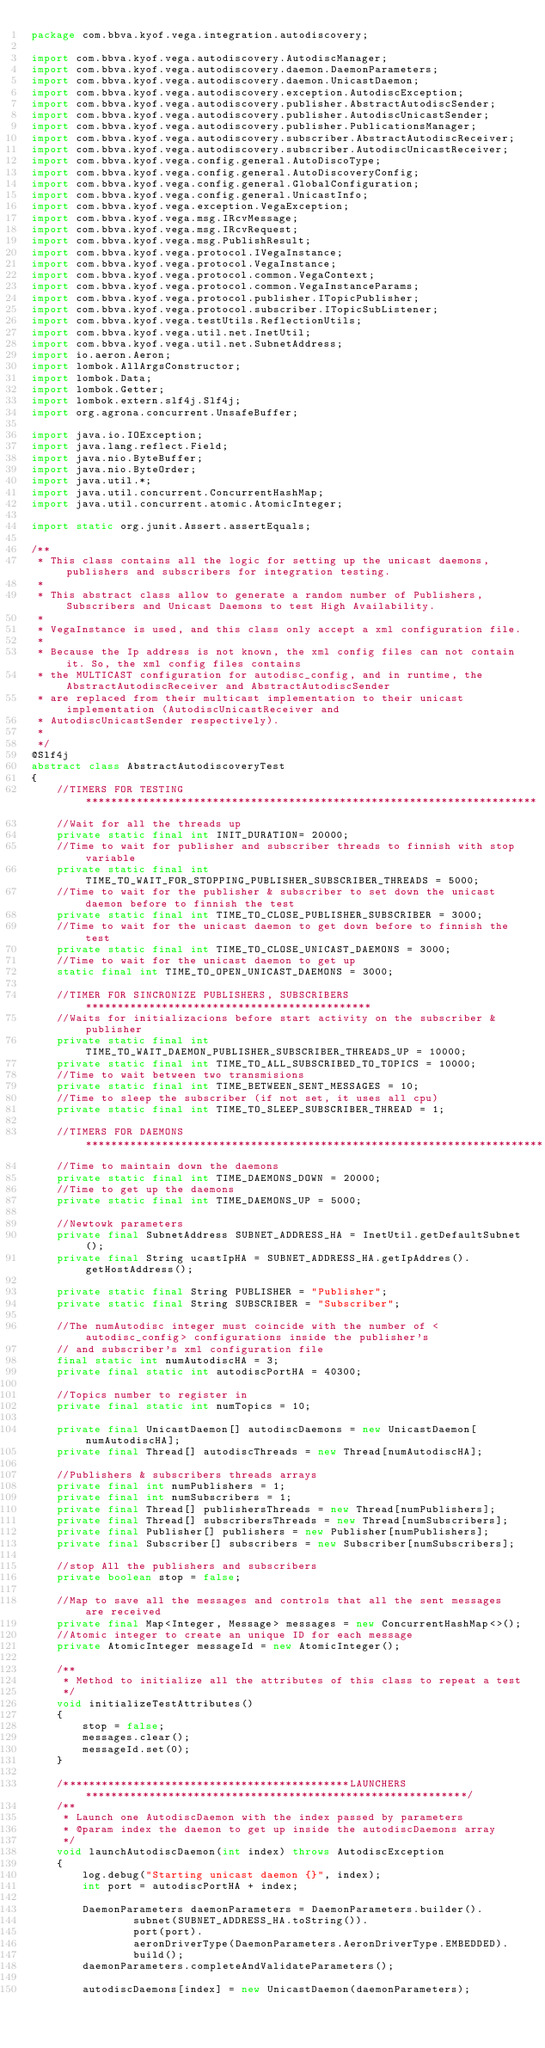Convert code to text. <code><loc_0><loc_0><loc_500><loc_500><_Java_>package com.bbva.kyof.vega.integration.autodiscovery;

import com.bbva.kyof.vega.autodiscovery.AutodiscManager;
import com.bbva.kyof.vega.autodiscovery.daemon.DaemonParameters;
import com.bbva.kyof.vega.autodiscovery.daemon.UnicastDaemon;
import com.bbva.kyof.vega.autodiscovery.exception.AutodiscException;
import com.bbva.kyof.vega.autodiscovery.publisher.AbstractAutodiscSender;
import com.bbva.kyof.vega.autodiscovery.publisher.AutodiscUnicastSender;
import com.bbva.kyof.vega.autodiscovery.publisher.PublicationsManager;
import com.bbva.kyof.vega.autodiscovery.subscriber.AbstractAutodiscReceiver;
import com.bbva.kyof.vega.autodiscovery.subscriber.AutodiscUnicastReceiver;
import com.bbva.kyof.vega.config.general.AutoDiscoType;
import com.bbva.kyof.vega.config.general.AutoDiscoveryConfig;
import com.bbva.kyof.vega.config.general.GlobalConfiguration;
import com.bbva.kyof.vega.config.general.UnicastInfo;
import com.bbva.kyof.vega.exception.VegaException;
import com.bbva.kyof.vega.msg.IRcvMessage;
import com.bbva.kyof.vega.msg.IRcvRequest;
import com.bbva.kyof.vega.msg.PublishResult;
import com.bbva.kyof.vega.protocol.IVegaInstance;
import com.bbva.kyof.vega.protocol.VegaInstance;
import com.bbva.kyof.vega.protocol.common.VegaContext;
import com.bbva.kyof.vega.protocol.common.VegaInstanceParams;
import com.bbva.kyof.vega.protocol.publisher.ITopicPublisher;
import com.bbva.kyof.vega.protocol.subscriber.ITopicSubListener;
import com.bbva.kyof.vega.testUtils.ReflectionUtils;
import com.bbva.kyof.vega.util.net.InetUtil;
import com.bbva.kyof.vega.util.net.SubnetAddress;
import io.aeron.Aeron;
import lombok.AllArgsConstructor;
import lombok.Data;
import lombok.Getter;
import lombok.extern.slf4j.Slf4j;
import org.agrona.concurrent.UnsafeBuffer;

import java.io.IOException;
import java.lang.reflect.Field;
import java.nio.ByteBuffer;
import java.nio.ByteOrder;
import java.util.*;
import java.util.concurrent.ConcurrentHashMap;
import java.util.concurrent.atomic.AtomicInteger;

import static org.junit.Assert.assertEquals;

/**
 * This class contains all the logic for setting up the unicast daemons, publishers and subscribers for integration testing.
 *
 * This abstract class allow to generate a random number of Publishers, Subscribers and Unicast Daemons to test High Availability.
 *
 * VegaInstance is used, and this class only accept a xml configuration file.
 *
 * Because the Ip address is not known, the xml config files can not contain it. So, the xml config files contains
 * the MULTICAST configuration for autodisc_config, and in runtime, the AbstractAutodiscReceiver and AbstractAutodiscSender
 * are replaced from their multicast implementation to their unicast implementation (AutodiscUnicastReceiver and
 * AutodiscUnicastSender respectively).
 *
 */
@Slf4j
abstract class AbstractAutodiscoveryTest
{
    //TIMERS FOR TESTING  ***********************************************************************
    //Wait for all the threads up
    private static final int INIT_DURATION= 20000;
    //Time to wait for publisher and subscriber threads to finnish with stop variable
    private static final int TIME_TO_WAIT_FOR_STOPPING_PUBLISHER_SUBSCRIBER_THREADS = 5000;
    //Time to wait for the publisher & subscriber to set down the unicast daemon before to finnish the test
    private static final int TIME_TO_CLOSE_PUBLISHER_SUBSCRIBER = 3000;
    //Time to wait for the unicast daemon to get down before to finnish the test
    private static final int TIME_TO_CLOSE_UNICAST_DAEMONS = 3000;
    //Time to wait for the unicast daemon to get up
    static final int TIME_TO_OPEN_UNICAST_DAEMONS = 3000;

    //TIMER FOR SINCRONIZE PUBLISHERS, SUBSCRIBERS  *********************************************
    //Waits for initializacions before start activity on the subscriber & publisher
    private static final int TIME_TO_WAIT_DAEMON_PUBLISHER_SUBSCRIBER_THREADS_UP = 10000;
    private static final int TIME_TO_ALL_SUBSCRIBED_TO_TOPICS = 10000;
    //Time to wait between two transmisions
    private static final int TIME_BETWEEN_SENT_MESSAGES = 10;
    //Time to sleep the subscriber (if not set, it uses all cpu)
    private static final int TIME_TO_SLEEP_SUBSCRIBER_THREAD = 1;

    //TIMERS FOR DAEMONS ************************************************************************
    //Time to maintain down the daemons
    private static final int TIME_DAEMONS_DOWN = 20000;
    //Time to get up the daemons
    private static final int TIME_DAEMONS_UP = 5000;

    //Newtowk parameters
    private final SubnetAddress SUBNET_ADDRESS_HA = InetUtil.getDefaultSubnet();
    private final String ucastIpHA = SUBNET_ADDRESS_HA.getIpAddres().getHostAddress();

    private static final String PUBLISHER = "Publisher";
    private static final String SUBSCRIBER = "Subscriber";

    //The numAutodisc integer must coincide with the number of <autodisc_config> configurations inside the publisher's
    // and subscriber's xml configuration file
    final static int numAutodiscHA = 3;
    private final static int autodiscPortHA = 40300;

    //Topics number to register in
    private final static int numTopics = 10;

    private final UnicastDaemon[] autodiscDaemons = new UnicastDaemon[numAutodiscHA];
    private final Thread[] autodiscThreads = new Thread[numAutodiscHA];

    //Publishers & subscribers threads arrays
    private final int numPublishers = 1;
    private final int numSubscribers = 1;
    private final Thread[] publishersThreads = new Thread[numPublishers];
    private final Thread[] subscribersThreads = new Thread[numSubscribers];
    private final Publisher[] publishers = new Publisher[numPublishers];
    private final Subscriber[] subscribers = new Subscriber[numSubscribers];

    //stop All the publishers and subscribers
    private boolean stop = false;

    //Map to save all the messages and controls that all the sent messages are received
    private final Map<Integer, Message> messages = new ConcurrentHashMap<>();
    //Atomic integer to create an unique ID for each message
    private AtomicInteger messageId = new AtomicInteger();

    /**
     * Method to initialize all the attributes of this class to repeat a test
     */
    void initializeTestAttributes()
    {
        stop = false;
        messages.clear();
        messageId.set(0);
    }

    /*********************************************LAUNCHERS************************************************************/
    /**
     * Launch one AutodiscDaemon with the index passed by parameters
     * @param index the daemon to get up inside the autodiscDaemons array
     */
    void launchAutodiscDaemon(int index) throws AutodiscException
    {
        log.debug("Starting unicast daemon {}", index);
        int port = autodiscPortHA + index;

        DaemonParameters daemonParameters = DaemonParameters.builder().
                subnet(SUBNET_ADDRESS_HA.toString()).
                port(port).
                aeronDriverType(DaemonParameters.AeronDriverType.EMBEDDED).
                build();
        daemonParameters.completeAndValidateParameters();

        autodiscDaemons[index] = new UnicastDaemon(daemonParameters);</code> 